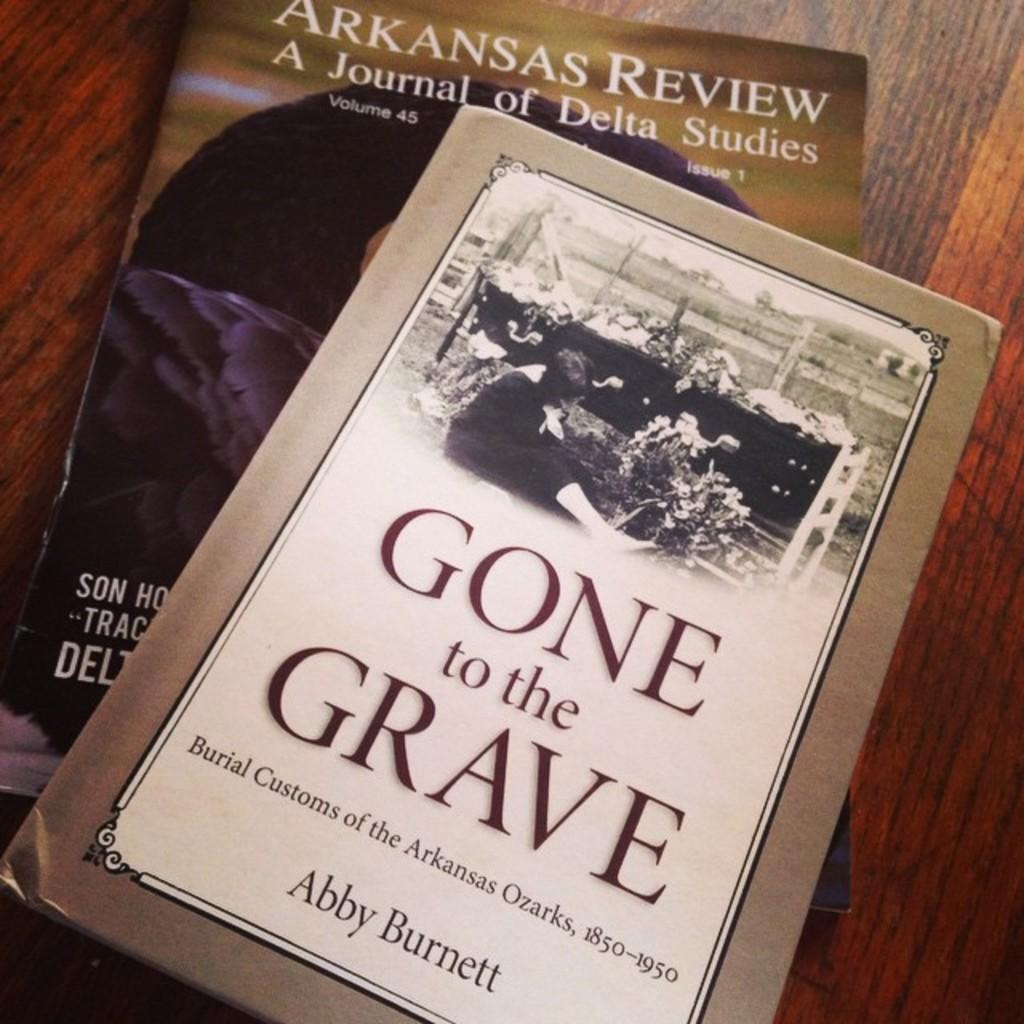Provide a one-sentence caption for the provided image. 2 books set on the table with the cover called gone to the grave. 